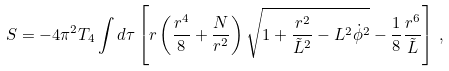Convert formula to latex. <formula><loc_0><loc_0><loc_500><loc_500>S = - 4 \pi ^ { 2 } T _ { 4 } \int d \tau \left [ r \left ( \frac { r ^ { 4 } } { 8 } + \frac { N } { r ^ { 2 } } \right ) \sqrt { 1 + \frac { r ^ { 2 } } { { \tilde { L } } ^ { 2 } } - L ^ { 2 } { \dot { \phi } } ^ { 2 } } - \frac { 1 } { 8 } \frac { r ^ { 6 } } { \tilde { L } } \right ] \, ,</formula> 